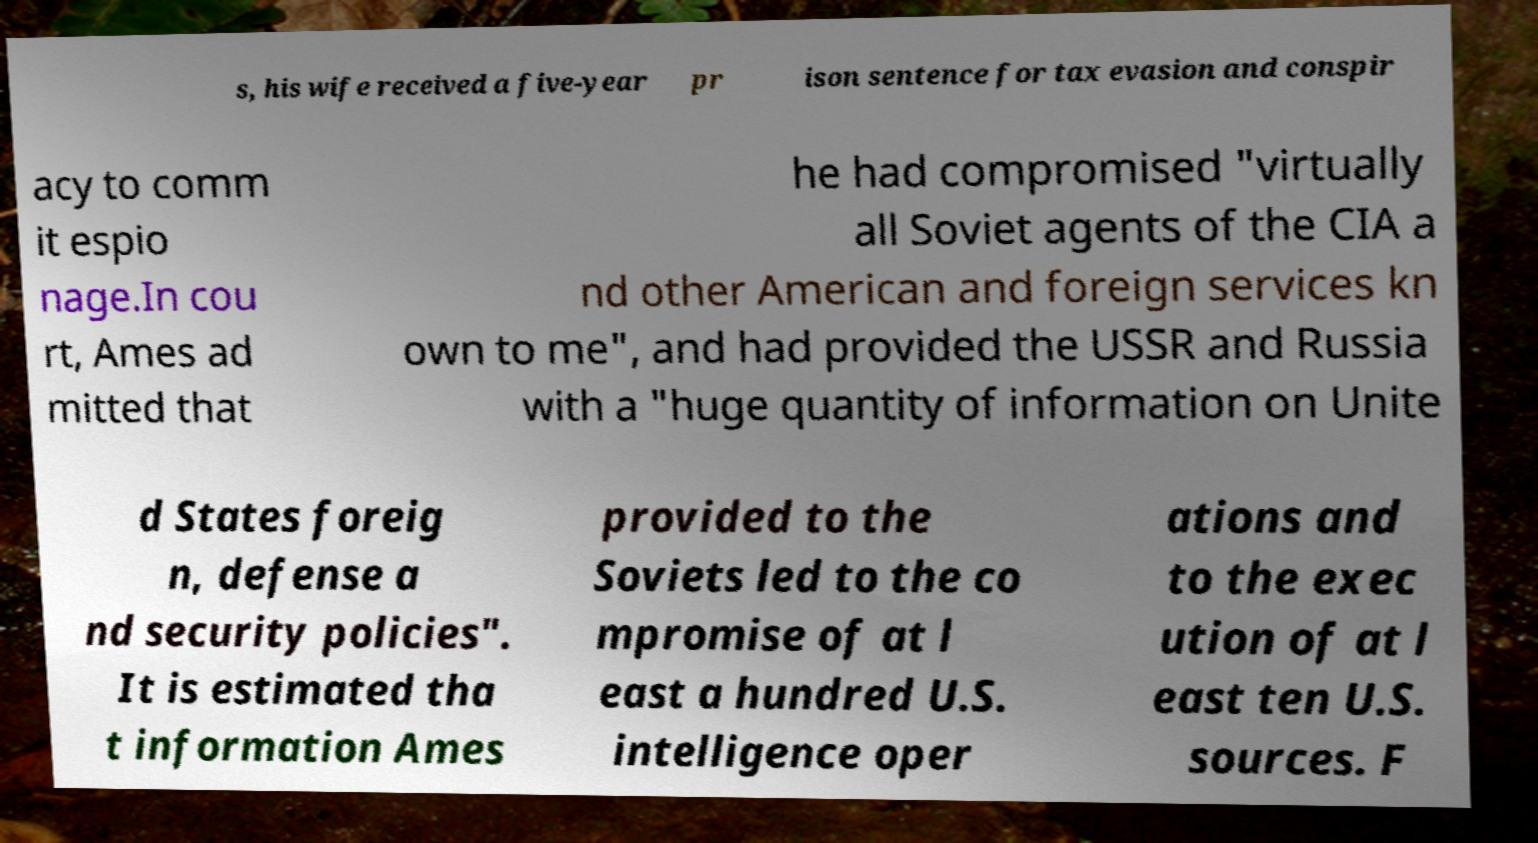Please read and relay the text visible in this image. What does it say? s, his wife received a five-year pr ison sentence for tax evasion and conspir acy to comm it espio nage.In cou rt, Ames ad mitted that he had compromised "virtually all Soviet agents of the CIA a nd other American and foreign services kn own to me", and had provided the USSR and Russia with a "huge quantity of information on Unite d States foreig n, defense a nd security policies". It is estimated tha t information Ames provided to the Soviets led to the co mpromise of at l east a hundred U.S. intelligence oper ations and to the exec ution of at l east ten U.S. sources. F 